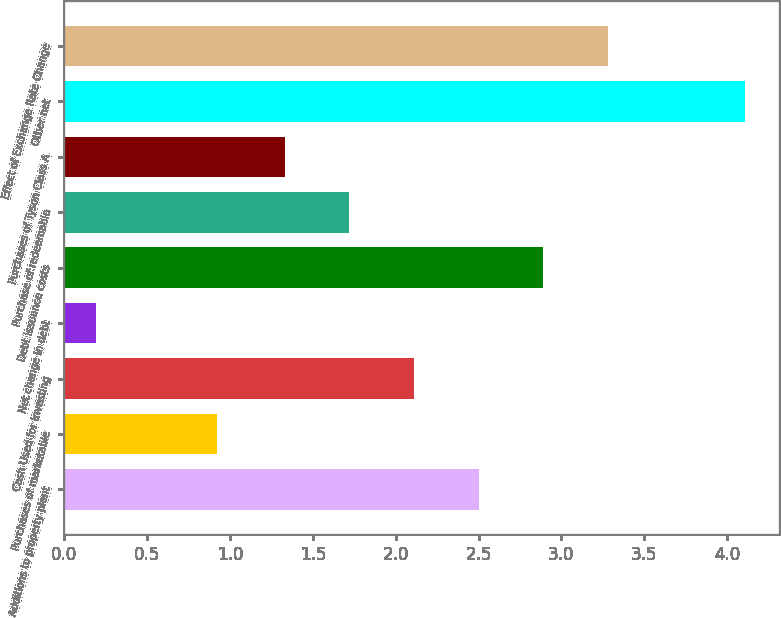Convert chart. <chart><loc_0><loc_0><loc_500><loc_500><bar_chart><fcel>Additions to property plant<fcel>Purchases of marketable<fcel>Cash Used for Investing<fcel>Net change in debt<fcel>Debt issuance costs<fcel>Purchase of redeemable<fcel>Purchases of Tyson Class A<fcel>Other net<fcel>Effect of Exchange Rate Change<nl><fcel>2.5<fcel>0.92<fcel>2.11<fcel>0.19<fcel>2.89<fcel>1.72<fcel>1.33<fcel>4.11<fcel>3.28<nl></chart> 